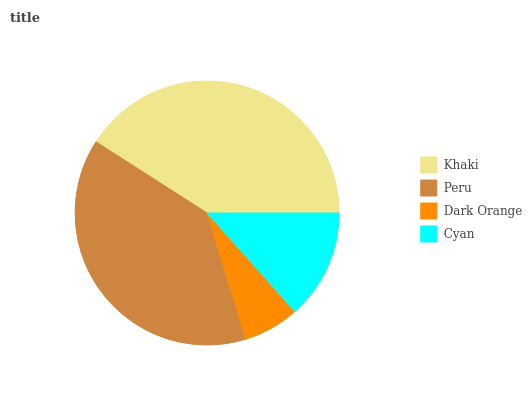Is Dark Orange the minimum?
Answer yes or no. Yes. Is Khaki the maximum?
Answer yes or no. Yes. Is Peru the minimum?
Answer yes or no. No. Is Peru the maximum?
Answer yes or no. No. Is Khaki greater than Peru?
Answer yes or no. Yes. Is Peru less than Khaki?
Answer yes or no. Yes. Is Peru greater than Khaki?
Answer yes or no. No. Is Khaki less than Peru?
Answer yes or no. No. Is Peru the high median?
Answer yes or no. Yes. Is Cyan the low median?
Answer yes or no. Yes. Is Cyan the high median?
Answer yes or no. No. Is Peru the low median?
Answer yes or no. No. 